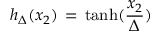Convert formula to latex. <formula><loc_0><loc_0><loc_500><loc_500>h _ { \Delta } ( x _ { 2 } ) \, = \, t a n h ( \frac { x _ { 2 } } { \Delta } )</formula> 